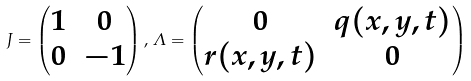Convert formula to latex. <formula><loc_0><loc_0><loc_500><loc_500>J = \begin{pmatrix} 1 & 0 \\ 0 & - 1 \end{pmatrix} , \, \varLambda = \begin{pmatrix} 0 & q ( x , y , t ) \\ r ( x , y , t ) & 0 \end{pmatrix}</formula> 